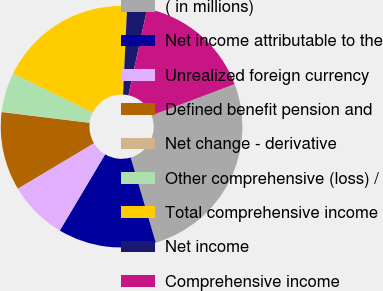Convert chart. <chart><loc_0><loc_0><loc_500><loc_500><pie_chart><fcel>( in millions)<fcel>Net income attributable to the<fcel>Unrealized foreign currency<fcel>Defined benefit pension and<fcel>Net change - derivative<fcel>Other comprehensive (loss) /<fcel>Total comprehensive income<fcel>Net income<fcel>Comprehensive income<nl><fcel>26.16%<fcel>13.11%<fcel>7.89%<fcel>10.5%<fcel>0.05%<fcel>5.27%<fcel>18.48%<fcel>2.66%<fcel>15.87%<nl></chart> 